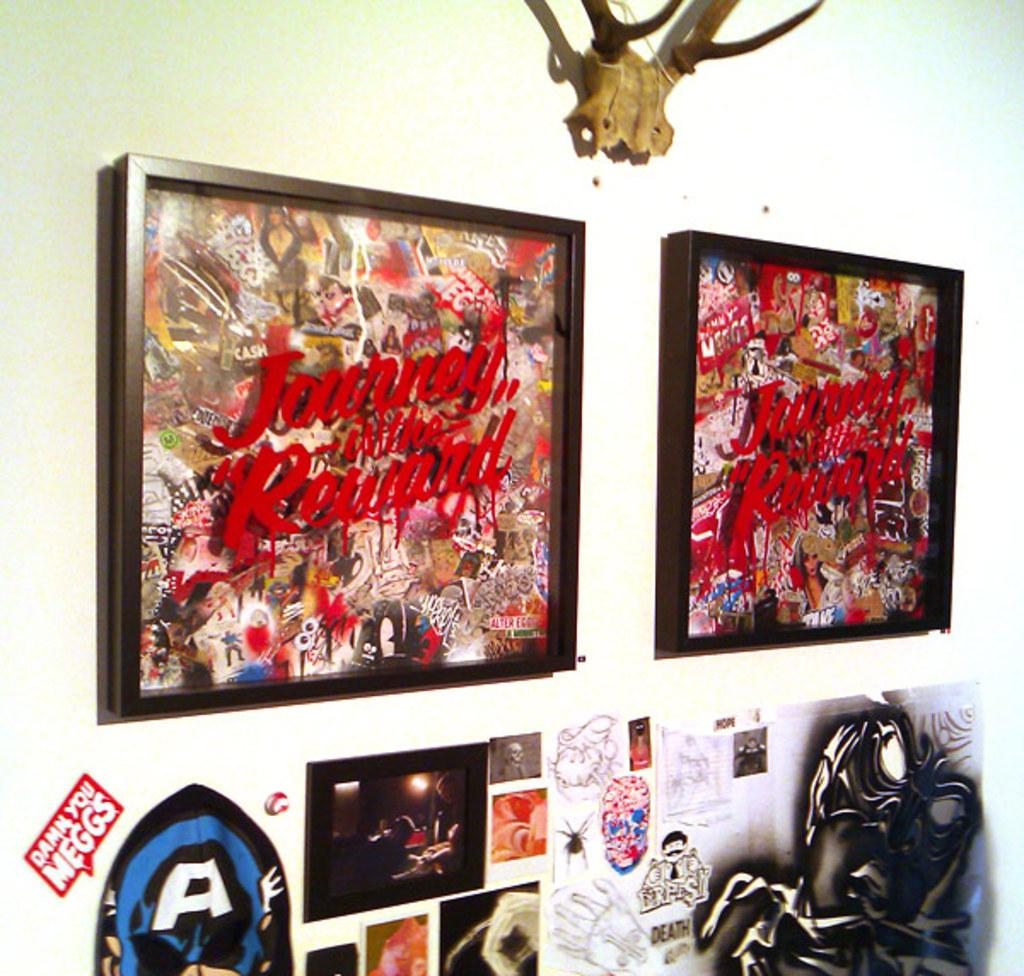<image>
Describe the image concisely. A wall with a few pictures displayed and a sticker saying "Damn you Meggs" 